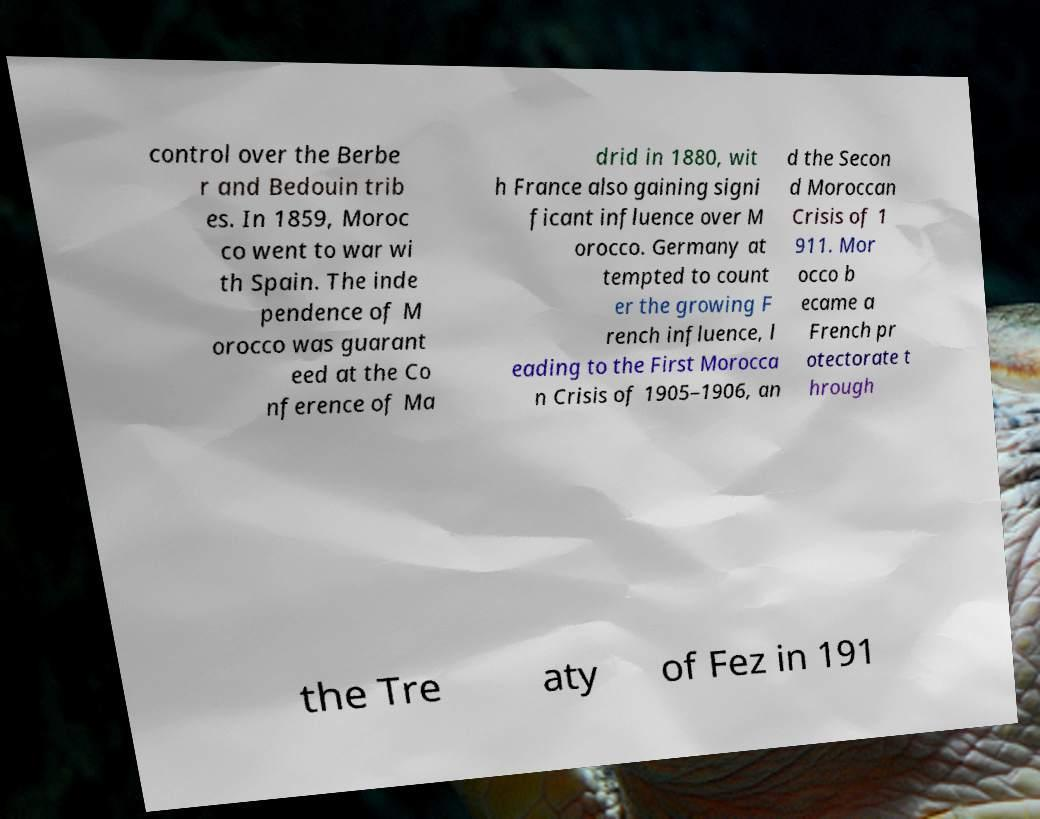Can you accurately transcribe the text from the provided image for me? control over the Berbe r and Bedouin trib es. In 1859, Moroc co went to war wi th Spain. The inde pendence of M orocco was guarant eed at the Co nference of Ma drid in 1880, wit h France also gaining signi ficant influence over M orocco. Germany at tempted to count er the growing F rench influence, l eading to the First Morocca n Crisis of 1905–1906, an d the Secon d Moroccan Crisis of 1 911. Mor occo b ecame a French pr otectorate t hrough the Tre aty of Fez in 191 